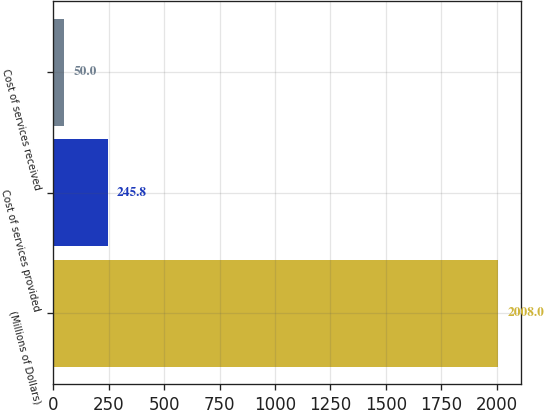<chart> <loc_0><loc_0><loc_500><loc_500><bar_chart><fcel>(Millions of Dollars)<fcel>Cost of services provided<fcel>Cost of services received<nl><fcel>2008<fcel>245.8<fcel>50<nl></chart> 